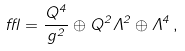<formula> <loc_0><loc_0><loc_500><loc_500>\epsilon = \frac { Q ^ { 4 } } { g ^ { 2 } } \oplus Q ^ { 2 } \Lambda ^ { 2 } \oplus \Lambda ^ { 4 } \, ,</formula> 